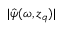<formula> <loc_0><loc_0><loc_500><loc_500>| \hat { \psi } ( \omega , z _ { q } ) |</formula> 